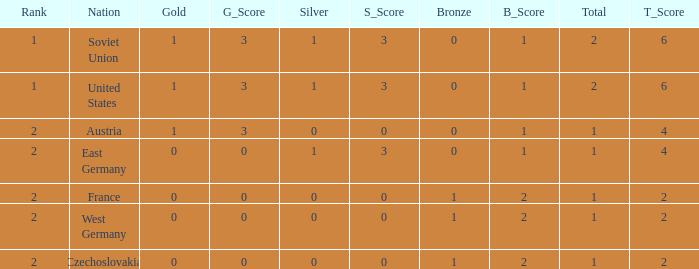What is the rank of the team with 0 gold and less than 0 silvers? None. 